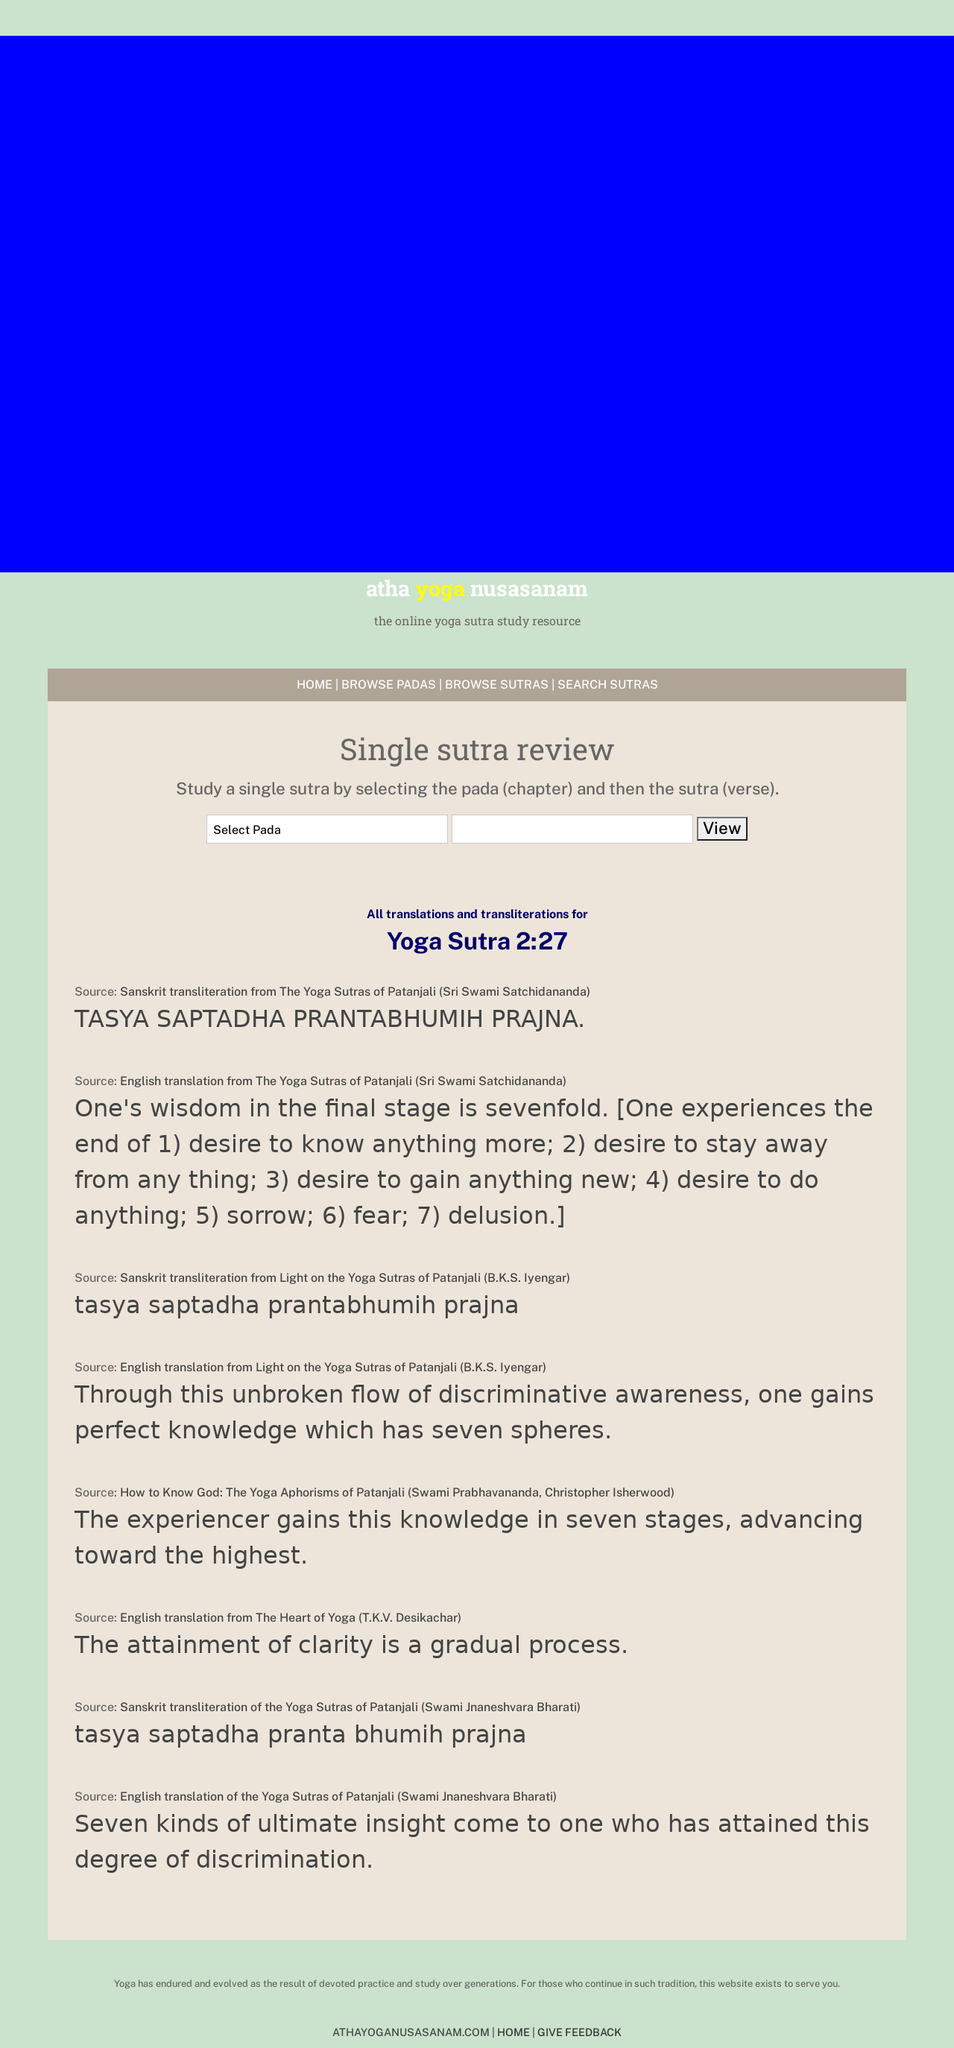How can I start building this website with HTML from the ground up? To begin building a website similar to the one shown in the image for Yoga Sutra study, you'll start with structuring your HTML to contain headers, navigation, and sections for content. Utilize CSS for styling elements according to your design preferences, ensuring navigation menus are clear and the layout is user-friendly. This basic structure aims to give you a starting point:

<!DOCTYPE html>
<html>
<head>
  <title>Yoga Sutra Study Resource</title>
  <link rel='stylesheet' href='styles.css'>
</head>
<body>
  <header>
    <h1>atha yoga nusasanam</h1>
    <nav>
      <ul>
        <li><a href='home'>HOME</a></li>
        <li><a href='suras_browse'>Browse Sutras</a></li>
        <li><a href='sutra_search'>Search Sutras</a></li>
      </ul>
    </nav>
  </header>
  <section>
    <article>
      <h2>Single Sutra Review</h2>
      <p>Study a single sutra by selecting the chapter and verse.</p>
    </article>
  </section>
  <footer>
    <p>Copyright 2021 Yoga Sutra Study</p>
  </footer>
</body>
</html>

Incorporate interactive features using JavaScript and consider accessibility to enhance user experience and SEO. 